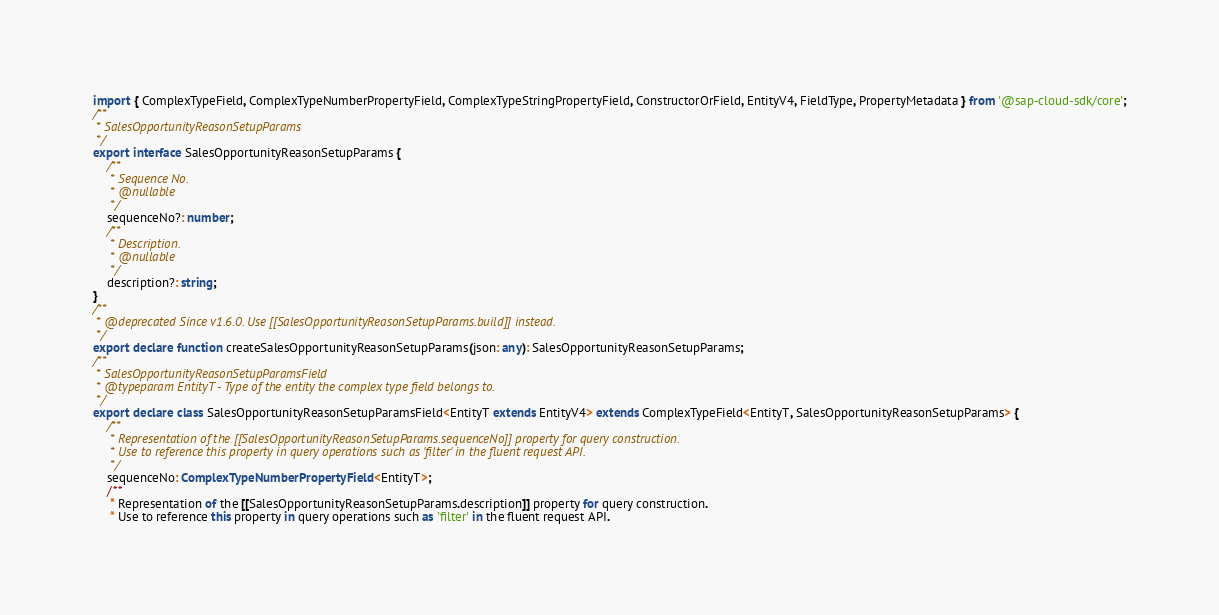<code> <loc_0><loc_0><loc_500><loc_500><_TypeScript_>import { ComplexTypeField, ComplexTypeNumberPropertyField, ComplexTypeStringPropertyField, ConstructorOrField, EntityV4, FieldType, PropertyMetadata } from '@sap-cloud-sdk/core';
/**
 * SalesOpportunityReasonSetupParams
 */
export interface SalesOpportunityReasonSetupParams {
    /**
     * Sequence No.
     * @nullable
     */
    sequenceNo?: number;
    /**
     * Description.
     * @nullable
     */
    description?: string;
}
/**
 * @deprecated Since v1.6.0. Use [[SalesOpportunityReasonSetupParams.build]] instead.
 */
export declare function createSalesOpportunityReasonSetupParams(json: any): SalesOpportunityReasonSetupParams;
/**
 * SalesOpportunityReasonSetupParamsField
 * @typeparam EntityT - Type of the entity the complex type field belongs to.
 */
export declare class SalesOpportunityReasonSetupParamsField<EntityT extends EntityV4> extends ComplexTypeField<EntityT, SalesOpportunityReasonSetupParams> {
    /**
     * Representation of the [[SalesOpportunityReasonSetupParams.sequenceNo]] property for query construction.
     * Use to reference this property in query operations such as 'filter' in the fluent request API.
     */
    sequenceNo: ComplexTypeNumberPropertyField<EntityT>;
    /**
     * Representation of the [[SalesOpportunityReasonSetupParams.description]] property for query construction.
     * Use to reference this property in query operations such as 'filter' in the fluent request API.</code> 